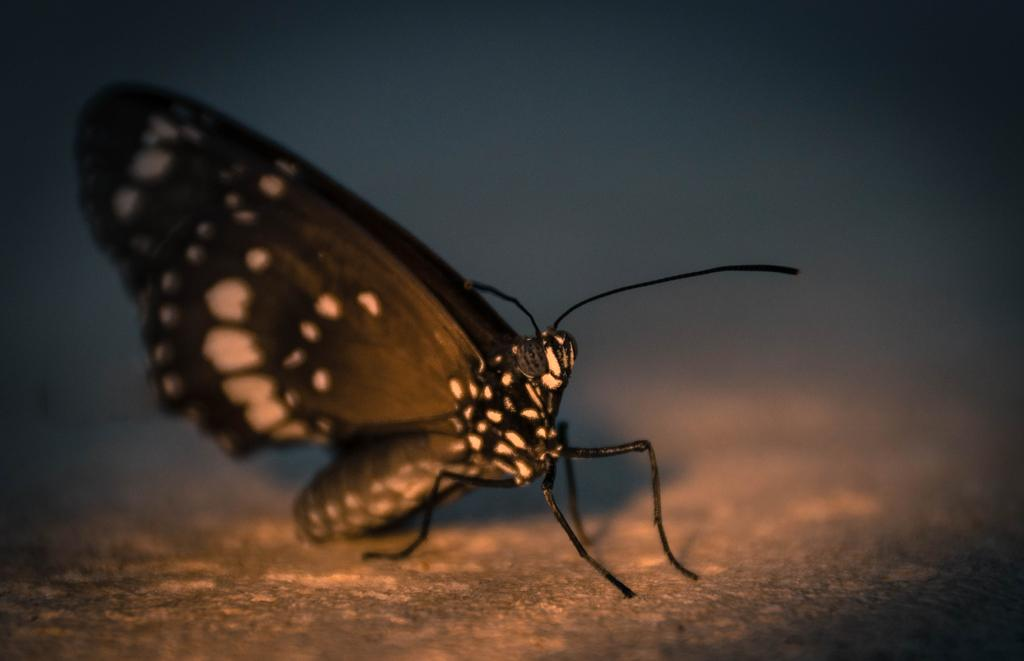What is the main subject of the image? There is a butterfly in the image. Can you describe the colors of the butterfly? The butterfly has brown and black colors. What is the butterfly resting on in the image? The butterfly is on a brown surface. What is the color of the background in the image? The background of the image is dark. What type of writing can be seen on the butterfly's wings in the image? There is no writing present on the butterfly's wings in the image. What kind of brush is being used by the butterfly in the image? There is no brush present in the image, and the butterfly is not depicted as using any tool. 